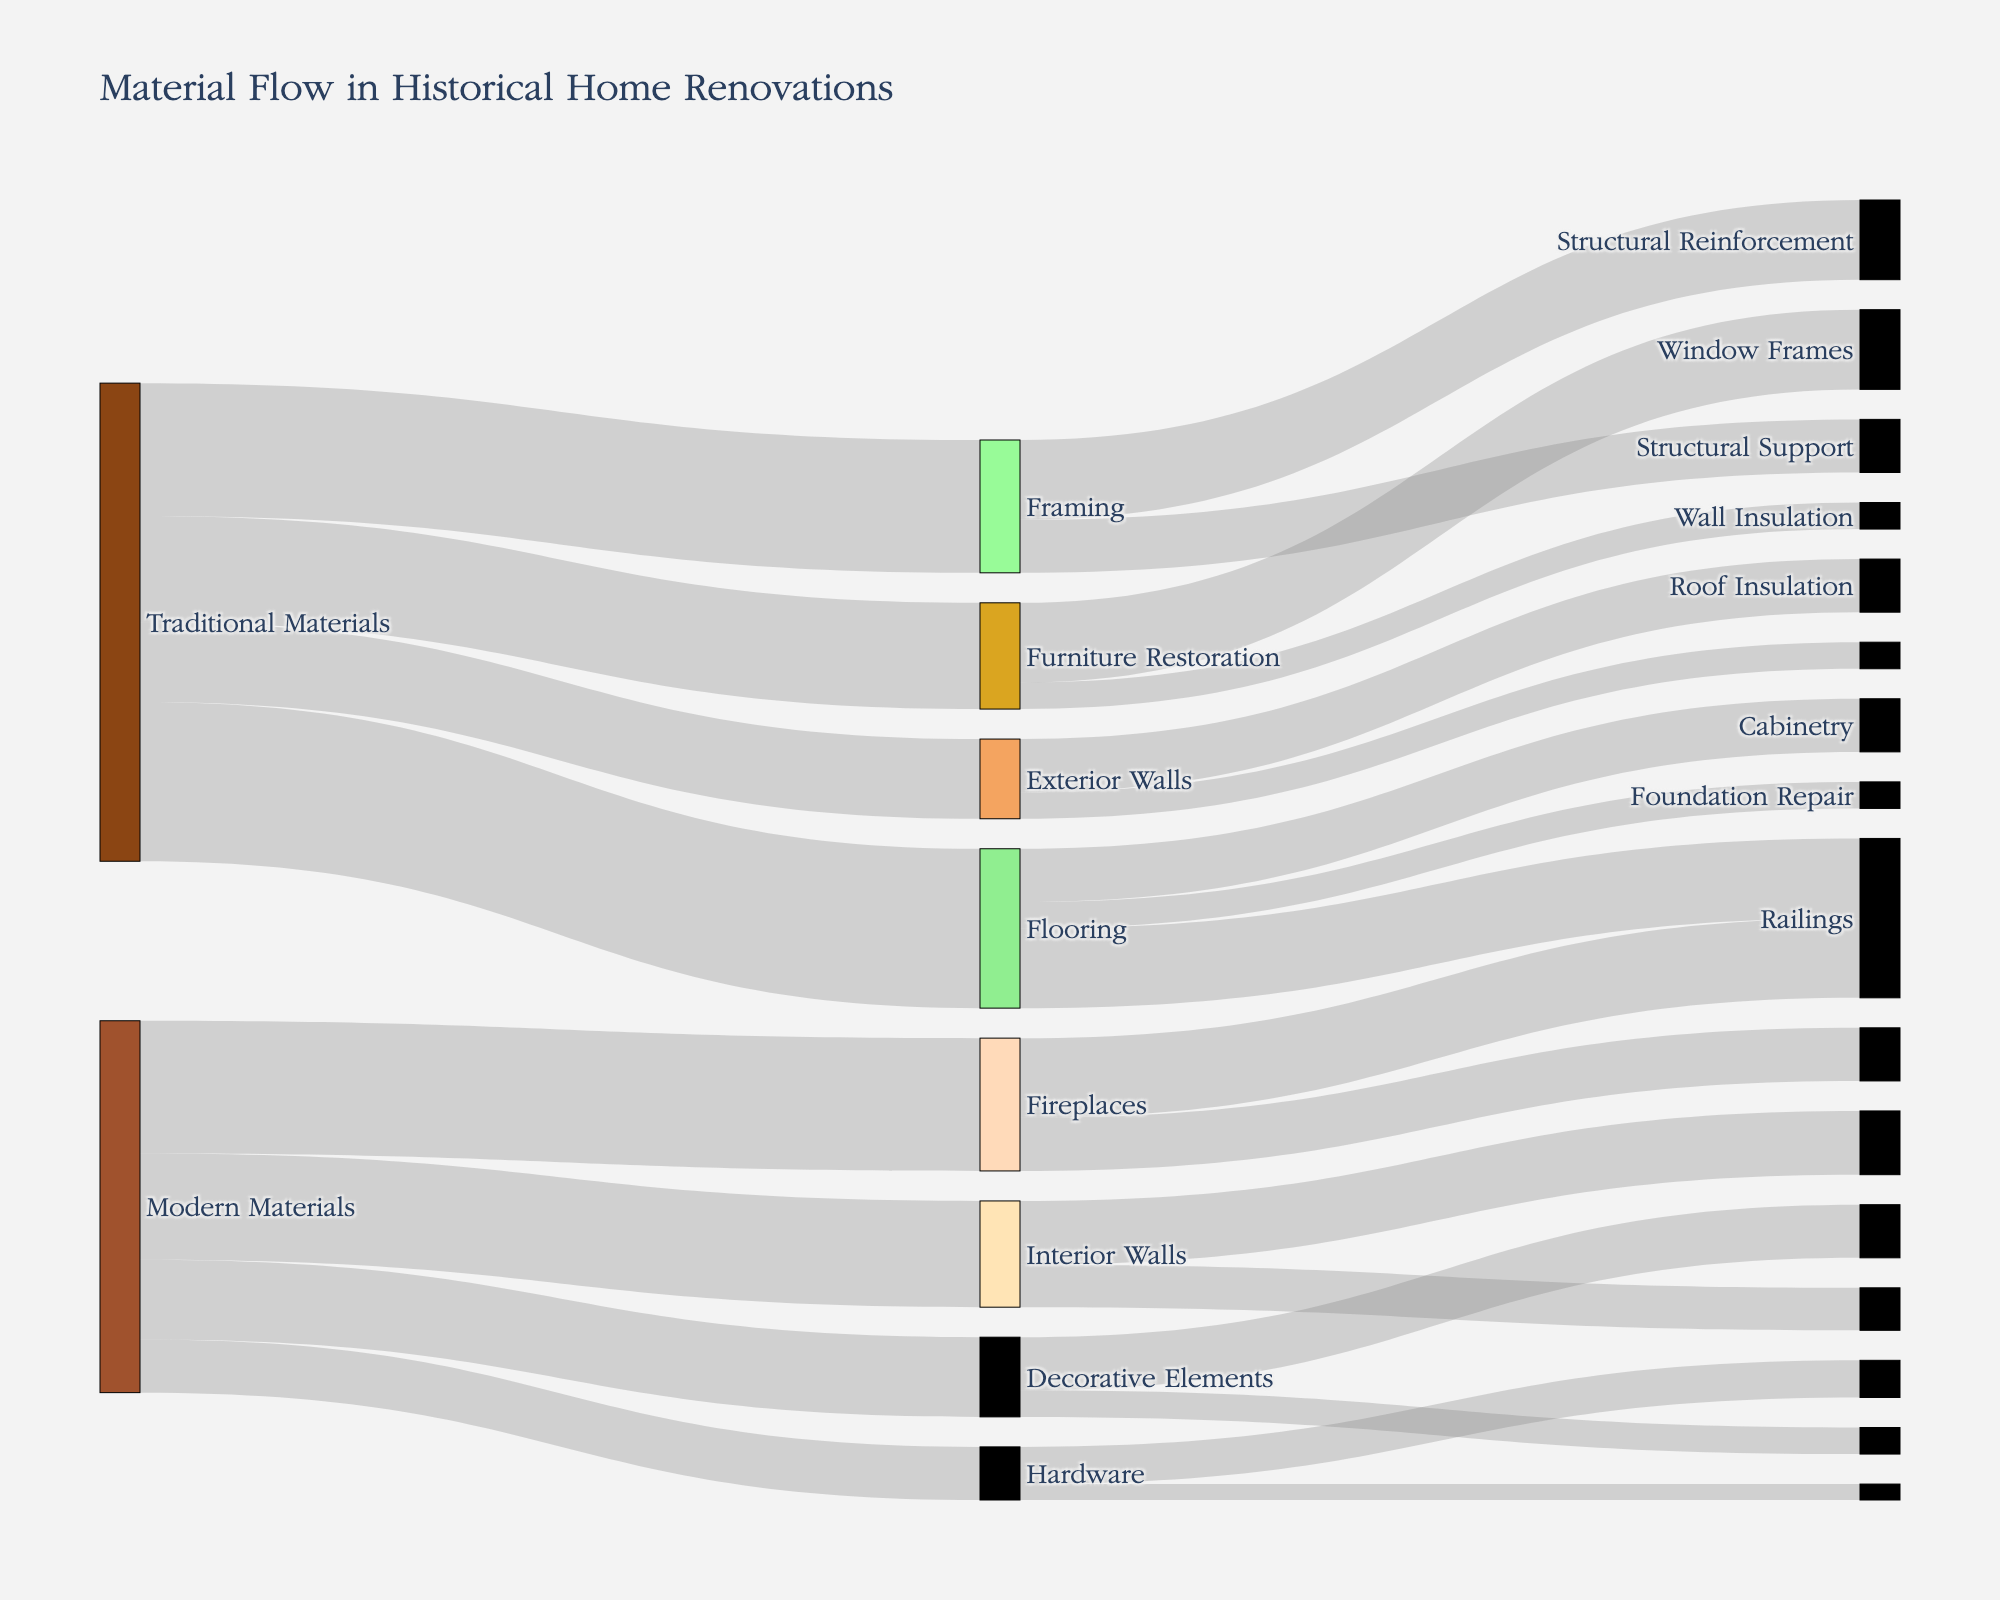Which material category provides the highest amount of flooring? To determine the material category that provides the highest amount for flooring, check the flows leading into the "Flooring" node. Wood contributes 15, and Engineered Wood also contributes 15. Comparing these, we see both have the same contribution.
Answer: Wood and Engineered Wood What is the total value of traditional materials used in interior walls? To find this, look at the connections from Lime Plaster to Interior Walls. The value is shown as 15.
Answer: 15 How much more Wood is used for Flooring than for Furniture Restoration? To find out how much more Wood is used for Flooring, subtract the value for Furniture Restoration from the value for Flooring. Flooring has 15 and Furniture Restoration has 5, so 15 - 5 = 10.
Answer: 10 Which material is most used in foundation repair? To find this, check the connections leading into the "Foundation Repair" node. Concrete is the material used with a value of 12.
Answer: Concrete How does the usage of traditional materials for exterior walls compare to the use of modern materials for structural support? Compare the values from Stone to Exterior Walls and Steel to Structural Support. Stone to Exterior Walls is 15, Steel to Structural Support is 10, so traditional materials are used 5 more units.
Answer: 5 more units for traditional materials Calculate the total value of modern materials used for restoration purposes (flooring, cabinetry). Look at the values connected to Flooring and Cabinetry from modern materials like Engineered Wood. Flooring has 15 and Cabinetry 10; 15 + 10 = 25.
Answer: 25 Which has a higher value in hardware usage, Wrought Iron or Steel? Compare the connections leading into Hardware. Wrought Iron has 10; Steel does not connect to Hardware. Therefore, Wrought Iron has a higher value.
Answer: Wrought Iron What percentage of Wood from traditional materials is used in Framing? Calculate the percentage of Wood used in Framing. Total Wood from Traditional Materials is 30, of which 10 is used in Framing. So, (10/30) * 100 = 33.33%.
Answer: 33.33% Which material is exclusively used in interior walls and decorative elements? To find a material used only in these two applications, check the nodes leading into these targets. Lime Plaster goes into Interior Walls (15) and Decorative Elements (5) and not to any other targets.
Answer: Lime Plaster How much more engineered wood is used for flooring compared to cabinetry? Subtract the cabinetry value from flooring value for Engineered Wood. Flooring has 15, Cabinetry has 10; 15 - 10 = 5.
Answer: 5 